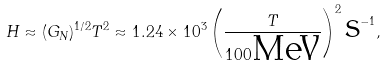Convert formula to latex. <formula><loc_0><loc_0><loc_500><loc_500>H \approx ( G _ { N } ) ^ { 1 / 2 } T ^ { 2 } \approx 1 . 2 4 \times 1 0 ^ { 3 } \left ( \frac { T } { 1 0 0 \text {MeV} } \right ) ^ { 2 } \text {s} ^ { - 1 } ,</formula> 